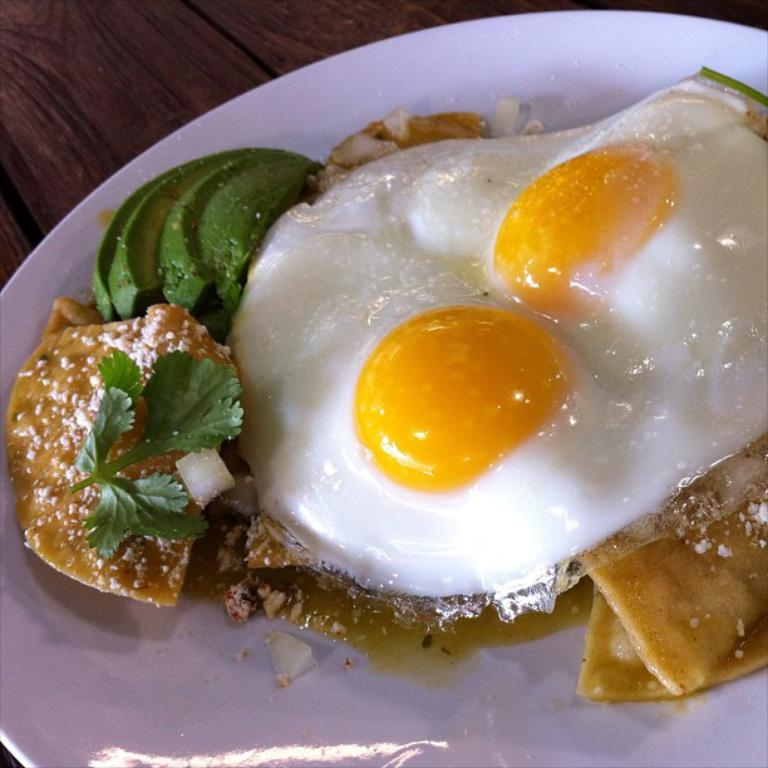What is located in the center of the image? There is a table in the center of the image. What is placed on the table? There is a plate on the table. What can be found on the plate? There are food items on the plate. What type of cable is being used to prepare the food on the plate? There is no cable present in the image, and no food preparation is shown. 